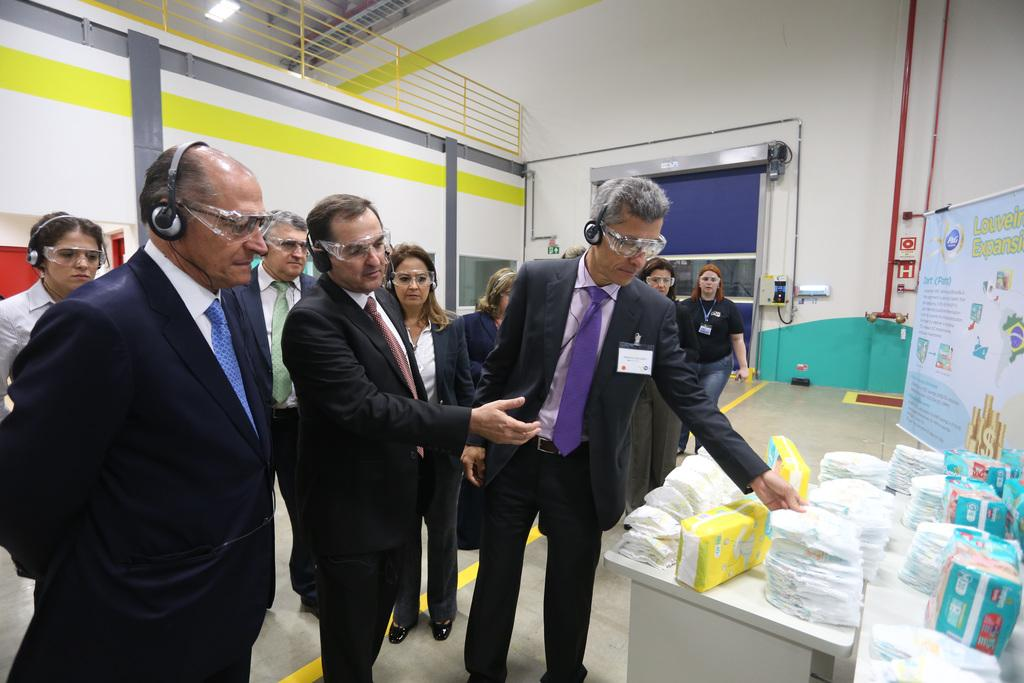How many men are in the image? There are three men in the image. What are the men wearing? All three men are wearing black coats. What can be seen on the right side of the image? There are objects on a table in the right side of the image. What is visible on the left side of the image? There is a light in the left side of the image. How many bricks are stacked on the table in the image? There are no bricks visible in the image; the objects on the table are not specified. Can you describe the stretch of the men's coats in the image? The men's coats are not described in terms of their stretch or fit in the image. 